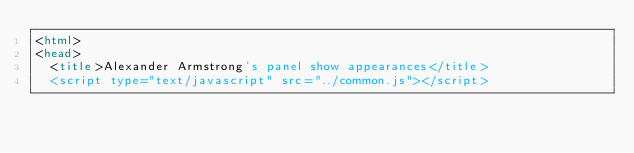Convert code to text. <code><loc_0><loc_0><loc_500><loc_500><_HTML_><html>
<head>
	<title>Alexander Armstrong's panel show appearances</title>
	<script type="text/javascript" src="../common.js"></script></code> 